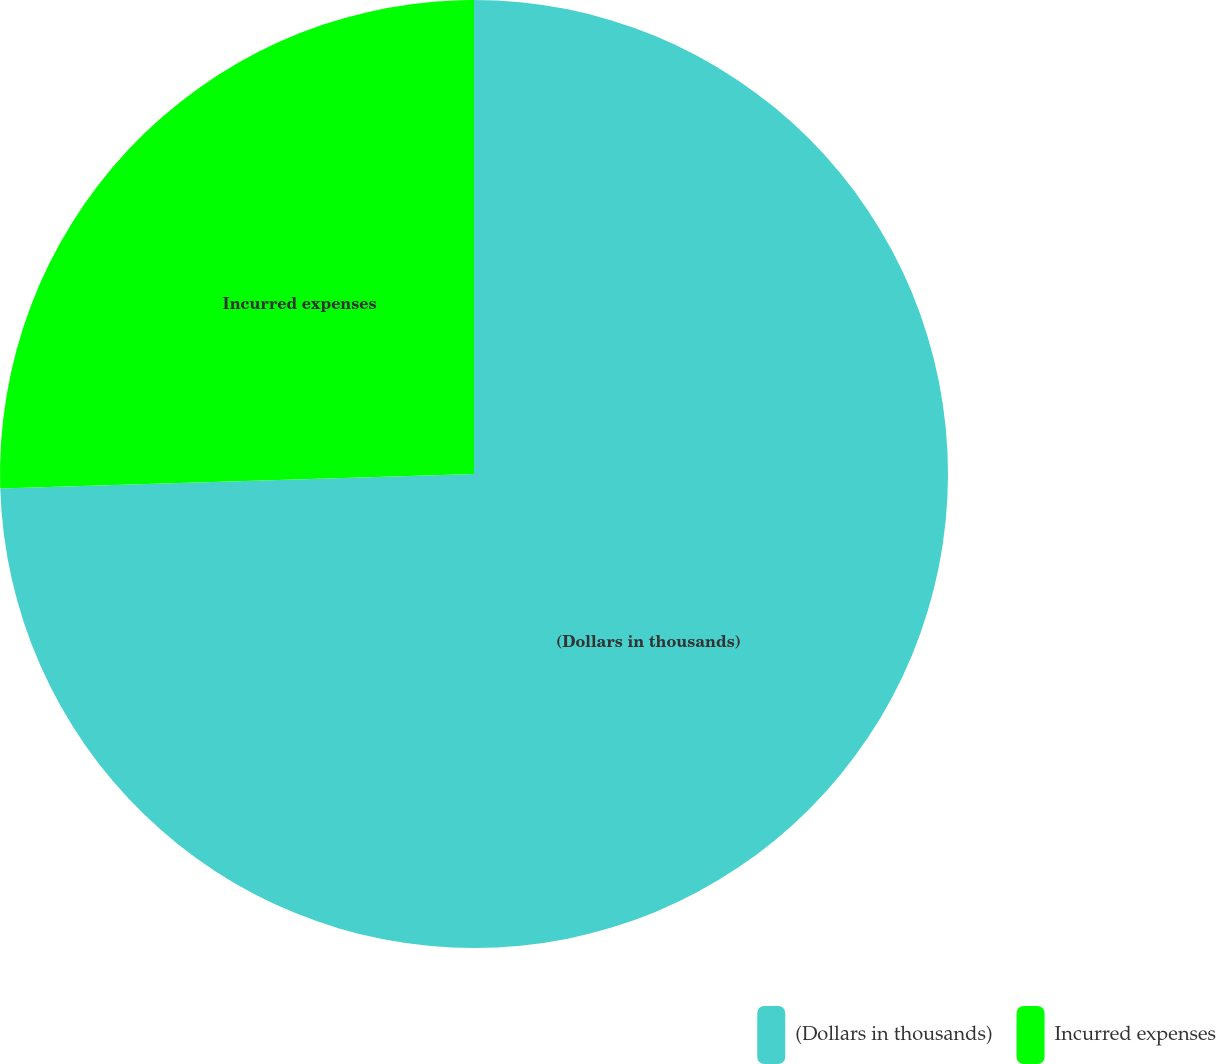<chart> <loc_0><loc_0><loc_500><loc_500><pie_chart><fcel>(Dollars in thousands)<fcel>Incurred expenses<nl><fcel>74.51%<fcel>25.49%<nl></chart> 